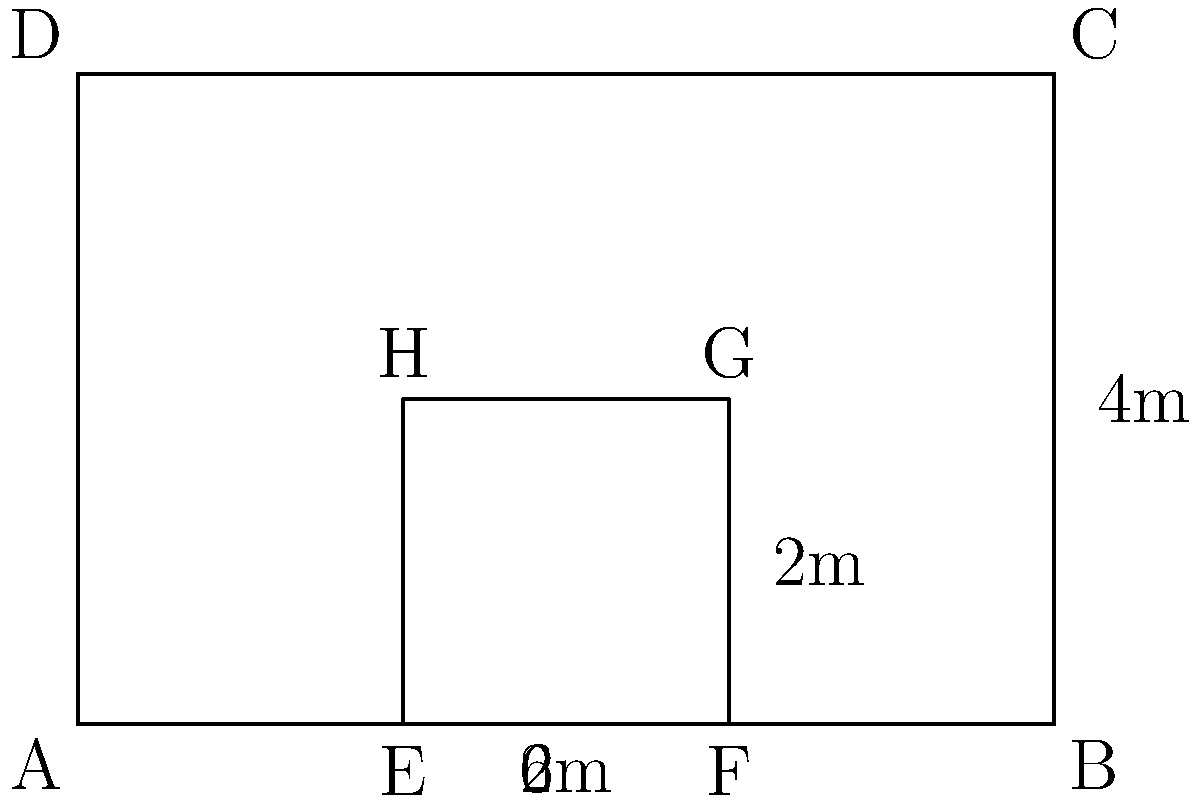As a farmer implementing an efficient irrigation system, you have a rectangular field measuring 6m by 4m. To conserve water and maximize crop yield, you decide to create a smaller rectangular plot within the field for intensive irrigation. If the inner rectangle has an area that is $\frac{1}{3}$ of the total field area, what is the perimeter of the inner rectangle? Let's solve this step-by-step:

1) First, calculate the area of the entire field:
   Area of field = $6m \times 4m = 24m^2$

2) The inner rectangle's area is $\frac{1}{3}$ of the total area:
   Area of inner rectangle = $\frac{1}{3} \times 24m^2 = 8m^2$

3) Let the width of the inner rectangle be $x$ and the length be $y$. We know:
   $xy = 8m^2$

4) From the diagram, we can see that the inner rectangle's width is 2m:
   $x = 2m$

5) We can now find $y$:
   $2m \times y = 8m^2$
   $y = 4m$

6) The inner rectangle's dimensions are 2m by 4m.

7) Calculate the perimeter:
   Perimeter = $2(length + width) = 2(4m + 2m) = 2(6m) = 12m$

Therefore, the perimeter of the inner rectangle is 12m.
Answer: 12m 